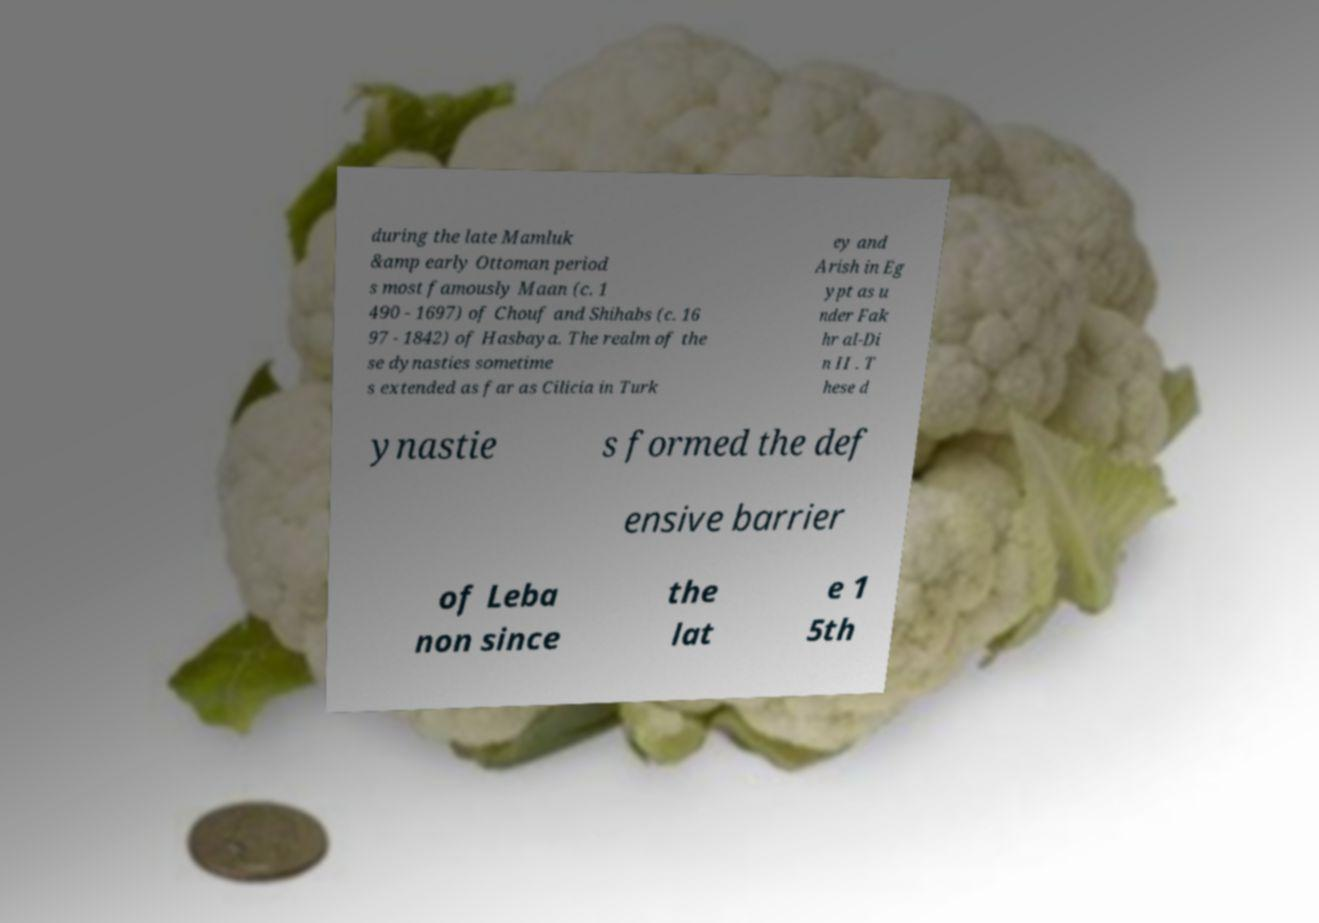Please read and relay the text visible in this image. What does it say? during the late Mamluk &amp early Ottoman period s most famously Maan (c. 1 490 - 1697) of Chouf and Shihabs (c. 16 97 - 1842) of Hasbaya. The realm of the se dynasties sometime s extended as far as Cilicia in Turk ey and Arish in Eg ypt as u nder Fak hr al-Di n II . T hese d ynastie s formed the def ensive barrier of Leba non since the lat e 1 5th 